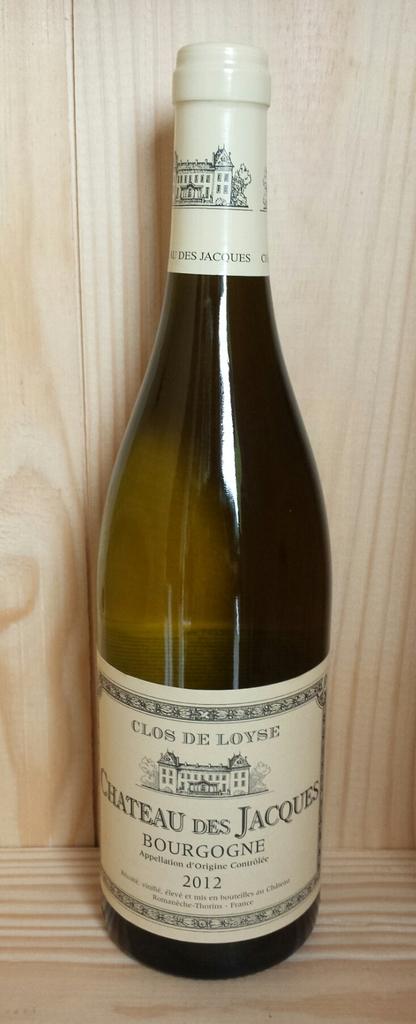What year was the beverage made?
Your answer should be very brief. 2012. What is the name of the beverage?
Offer a terse response. Bourgogne. 